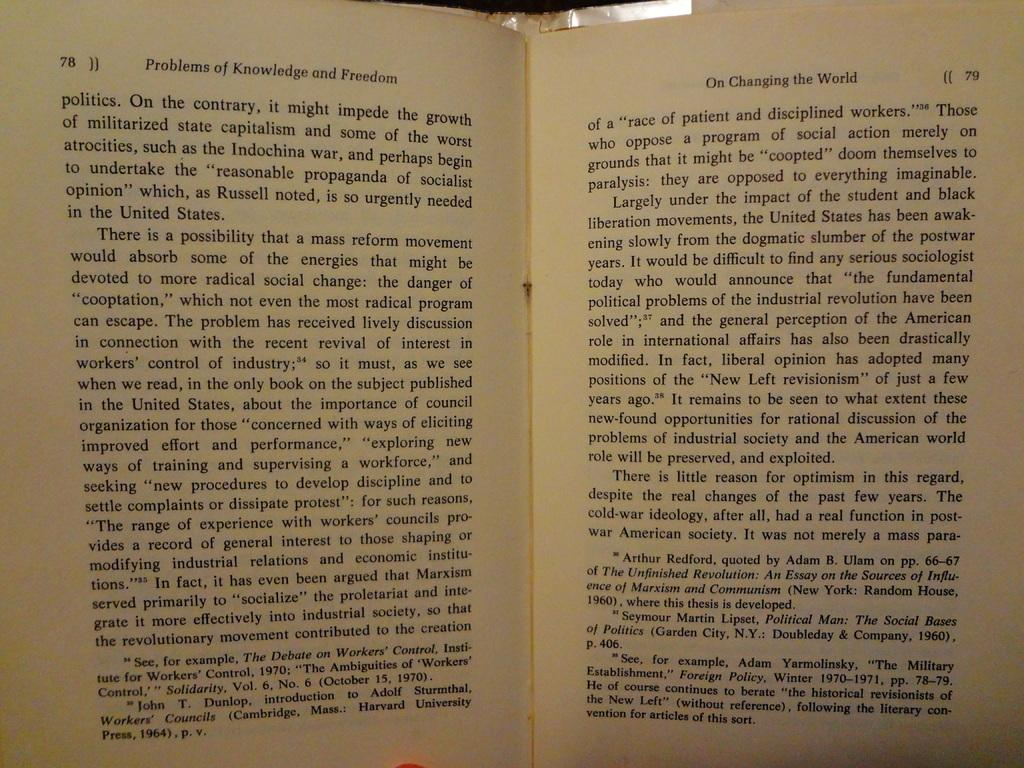<image>
Give a short and clear explanation of the subsequent image. The book Problems of Knowledge and Freedom opened to page 78 and 79. 